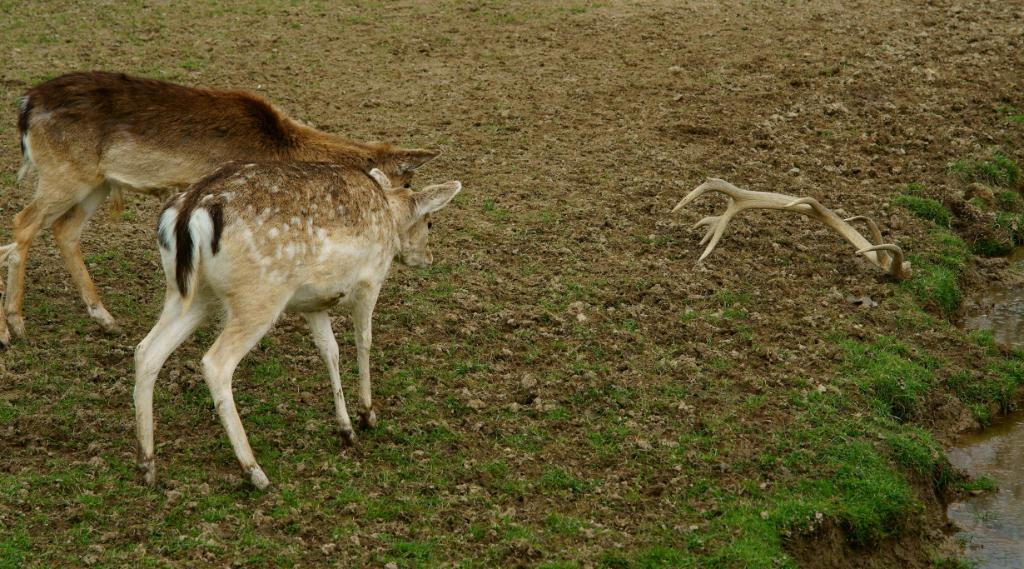What type of animals can be seen in the image? There are deer in the image. What is the color of the grass in the image? The grass on the ground in the image is green. What else can be seen in the image besides the deer? There is water visible in the image. What feature of the deer is visible in the image? The horns of a deer are visible in the image. Are there any fairies playing on a swing in the image? There are no fairies or swings present in the image. 